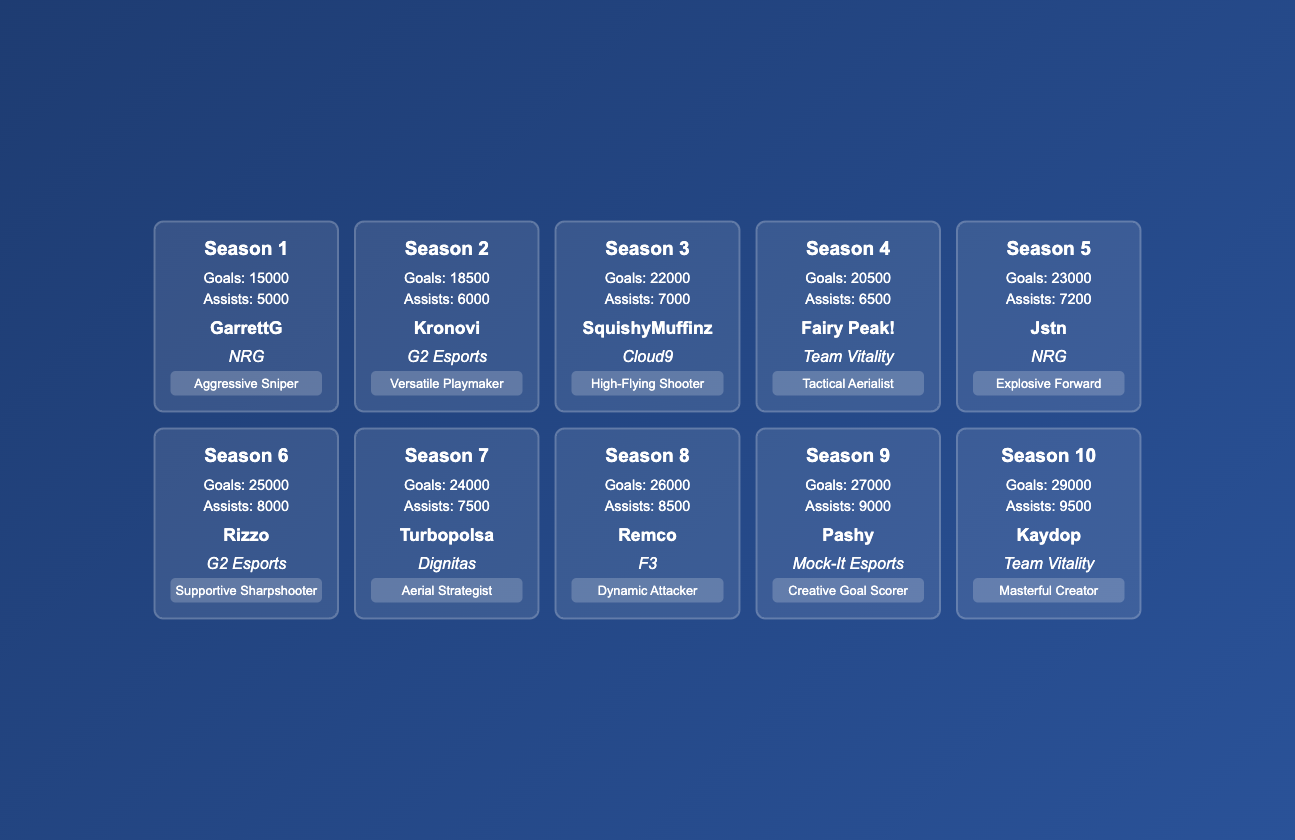What season had the most goals scored? The maximum value in the "Goals" column is 29000, corresponding to "Season 10".
Answer: Season 10 Who was the top player in Season 5? The table lists "Jstn" as the top player for "Season 5".
Answer: Jstn Which season had the lowest number of assists? Scanning through the "Assists" column, the minimum value is 5000 from "Season 1".
Answer: Season 1 What is the total number of goals scored across all seasons? Adding the values of the "Goals" column gives: 15000 + 18500 + 22000 + 20500 + 23000 + 25000 + 24000 + 26000 + 27000 + 29000 = 2,205,000.
Answer: 2205000 Did Season 8 have more goals than Season 6? "Season 8" scored 26000 goals while "Season 6" scored 25000 goals. Since 26000 is greater than 25000, the statement is true.
Answer: Yes Which playstyle had the most assists in Season 3? "Season 3" had 7000 assists, and the playstyle listed is "High-Flying Shooter". Therefore, the player with this playstyle had the most assists in that season.
Answer: High-Flying Shooter What is the average number of goals scored across the first five seasons? The sum of goals from the first five seasons is 15000 + 18500 + 22000 + 20500 + 23000 = 108000. There are 5 seasons, so the average is 108000 / 5 = 21600.
Answer: 21600 Which team had the player with the highest assists? The table shows "Team Vitality" with "Kaydop" having 9500 assists in "Season 10", which is the highest assists overall.
Answer: Team Vitality Is it true that all seasons after Season 5 had more goals than Season 5? The goals for "Season 5" is 23000. The subsequent seasons (6, 7, 8, 9, and 10) have 25000, 24000, 26000, 27000, and 29000 goals respectively. While Seasons 6, 8, 9, and 10 have more goals, Season 7 has less. Thus, the statement is false.
Answer: No 